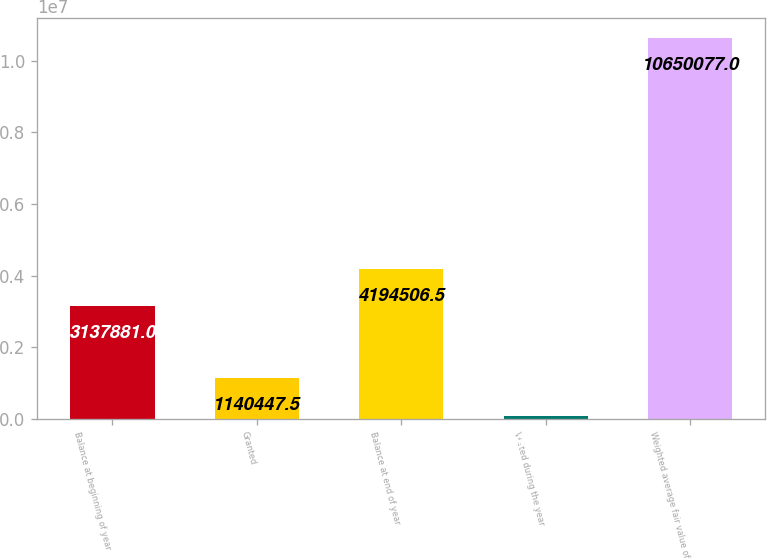<chart> <loc_0><loc_0><loc_500><loc_500><bar_chart><fcel>Balance at beginning of year<fcel>Granted<fcel>Balance at end of year<fcel>Vested during the year<fcel>Weighted average fair value of<nl><fcel>3.13788e+06<fcel>1.14045e+06<fcel>4.19451e+06<fcel>83822<fcel>1.06501e+07<nl></chart> 